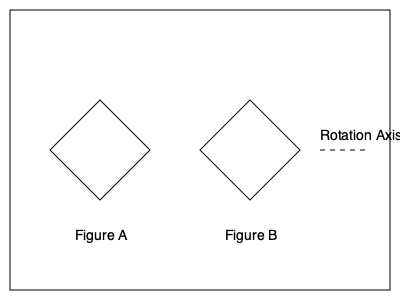In a military equipment assembly task, you encounter two 3D objects as shown in Figure A and Figure B. If Figure A is rotated 180 degrees around the indicated rotation axis, which statement best describes its relationship to Figure B? To solve this problem, let's follow these steps:

1. Observe Figure A carefully. It's a diamond-shaped object with its pointy ends at the top and bottom.

2. Imagine rotating Figure A 180 degrees around the horizontal axis shown:
   - The top point will move to the bottom.
   - The bottom point will move to the top.
   - The left and right points will swap positions.

3. After rotation, Figure A would look like this:
   - Pointy ends on the left and right sides.
   - Flat edges on the top and bottom.

4. Now, compare this mentally rotated Figure A with Figure B:
   - Figure B also has pointy ends on the left and right sides.
   - Figure B also has flat edges on the top and bottom.

5. The shapes are identical in orientation after the rotation.

This mental rotation exercise is similar to tasks you might encounter in military equipment assembly, where understanding spatial relationships is crucial for efficient and accurate work.
Answer: Identical to Figure B 